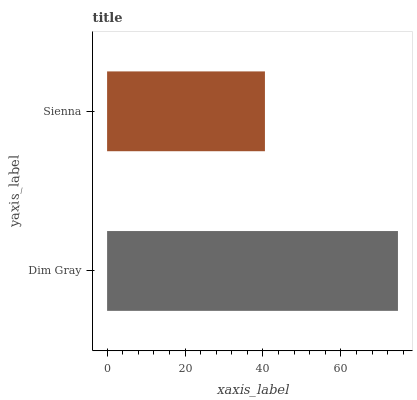Is Sienna the minimum?
Answer yes or no. Yes. Is Dim Gray the maximum?
Answer yes or no. Yes. Is Sienna the maximum?
Answer yes or no. No. Is Dim Gray greater than Sienna?
Answer yes or no. Yes. Is Sienna less than Dim Gray?
Answer yes or no. Yes. Is Sienna greater than Dim Gray?
Answer yes or no. No. Is Dim Gray less than Sienna?
Answer yes or no. No. Is Dim Gray the high median?
Answer yes or no. Yes. Is Sienna the low median?
Answer yes or no. Yes. Is Sienna the high median?
Answer yes or no. No. Is Dim Gray the low median?
Answer yes or no. No. 